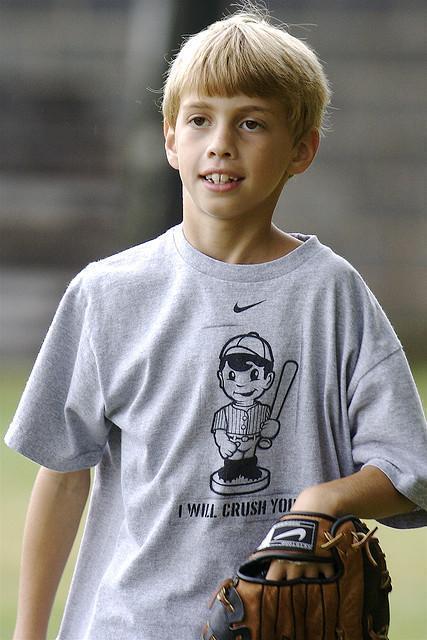How many glasses of orange juice are in the tray in the image?
Give a very brief answer. 0. 